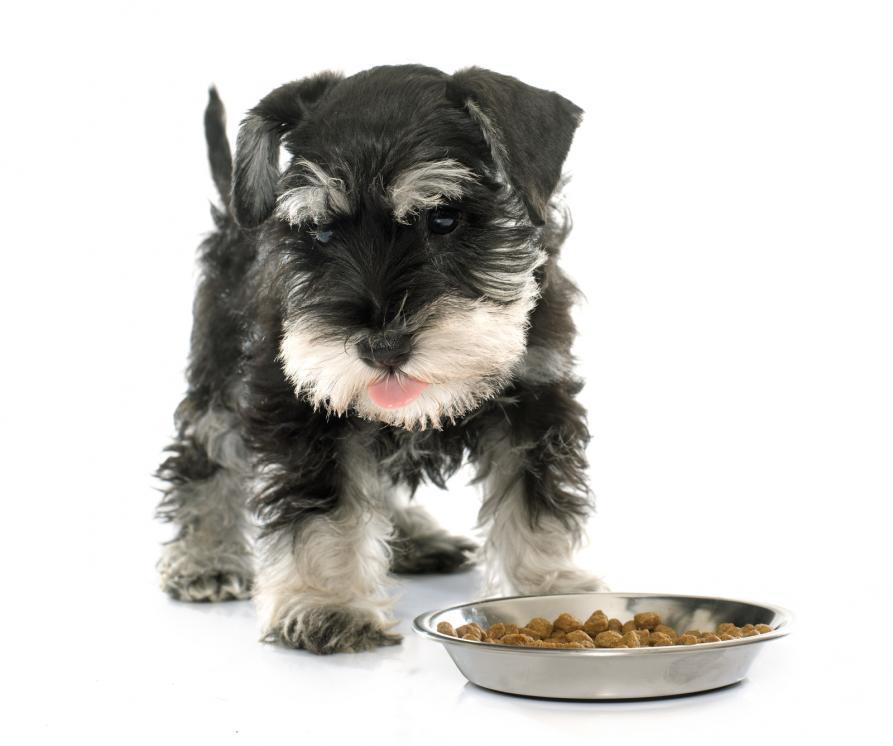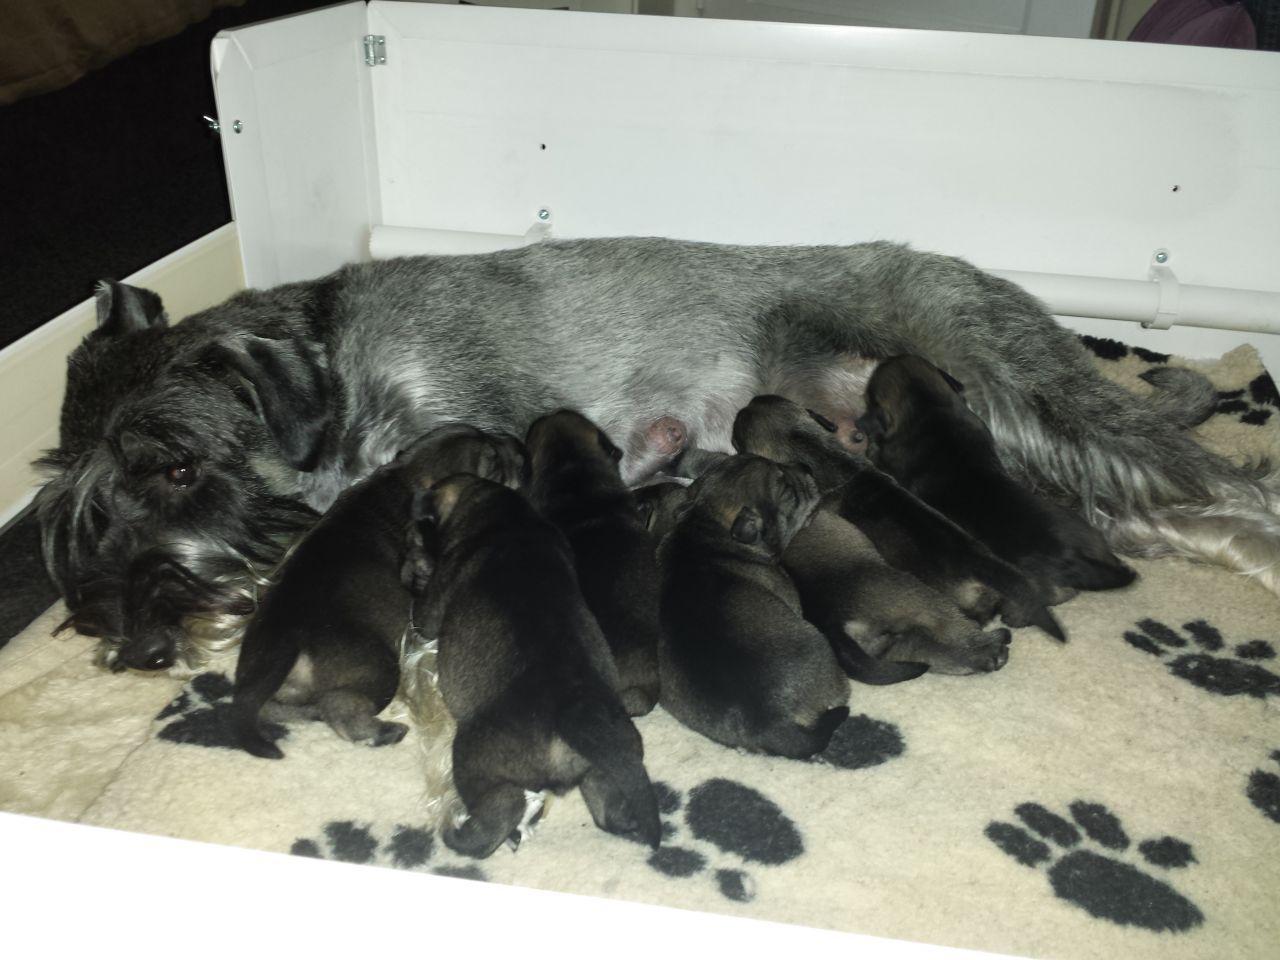The first image is the image on the left, the second image is the image on the right. Given the left and right images, does the statement "One image shows a groomed schnauzer standing on an elevated black surface facing leftward." hold true? Answer yes or no. No. 